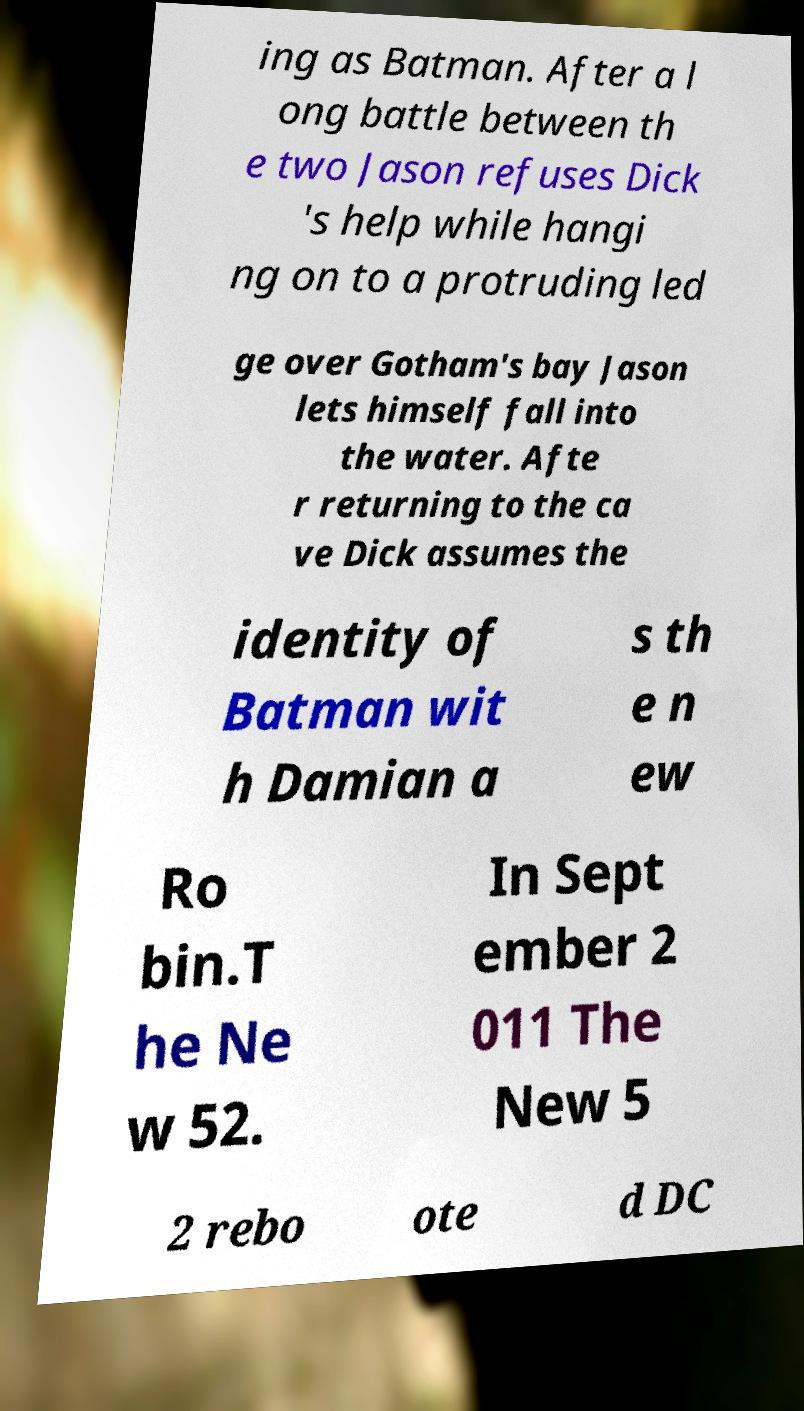What messages or text are displayed in this image? I need them in a readable, typed format. ing as Batman. After a l ong battle between th e two Jason refuses Dick 's help while hangi ng on to a protruding led ge over Gotham's bay Jason lets himself fall into the water. Afte r returning to the ca ve Dick assumes the identity of Batman wit h Damian a s th e n ew Ro bin.T he Ne w 52. In Sept ember 2 011 The New 5 2 rebo ote d DC 